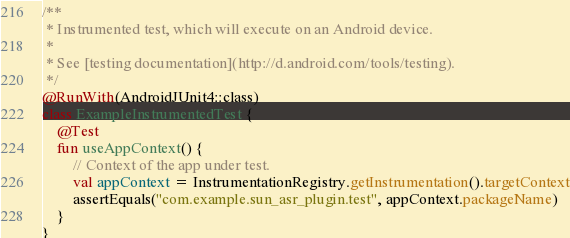Convert code to text. <code><loc_0><loc_0><loc_500><loc_500><_Kotlin_>
/**
 * Instrumented test, which will execute on an Android device.
 *
 * See [testing documentation](http://d.android.com/tools/testing).
 */
@RunWith(AndroidJUnit4::class)
class ExampleInstrumentedTest {
    @Test
    fun useAppContext() {
        // Context of the app under test.
        val appContext = InstrumentationRegistry.getInstrumentation().targetContext
        assertEquals("com.example.sun_asr_plugin.test", appContext.packageName)
    }
}</code> 